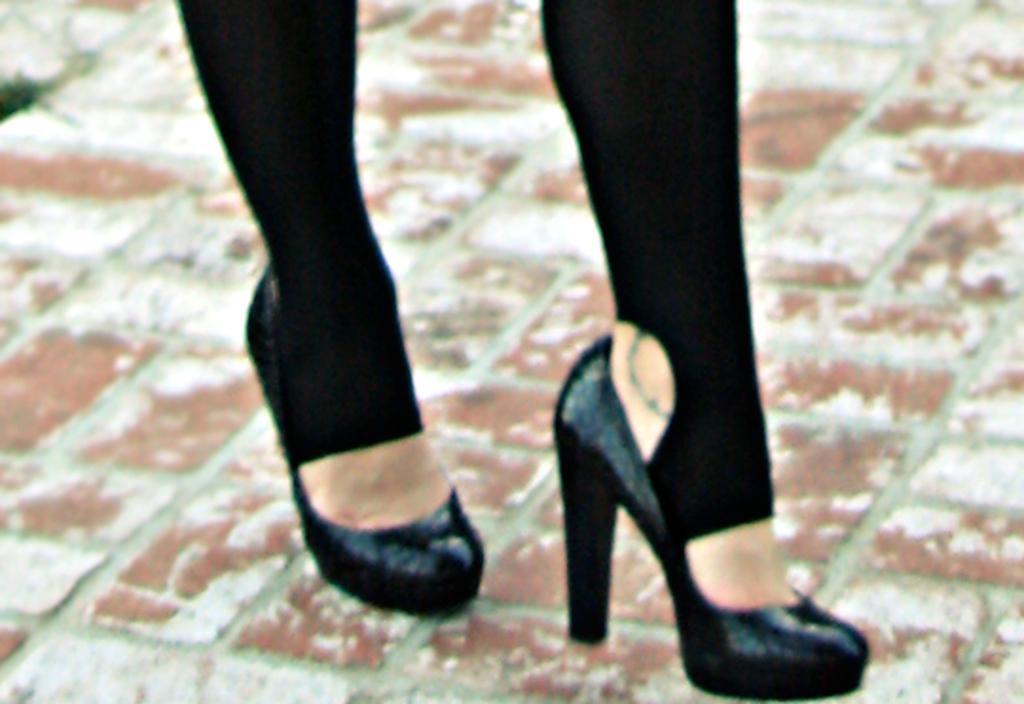Can you describe this image briefly? In this image we can see the person's legs with black shoes on the floor. 